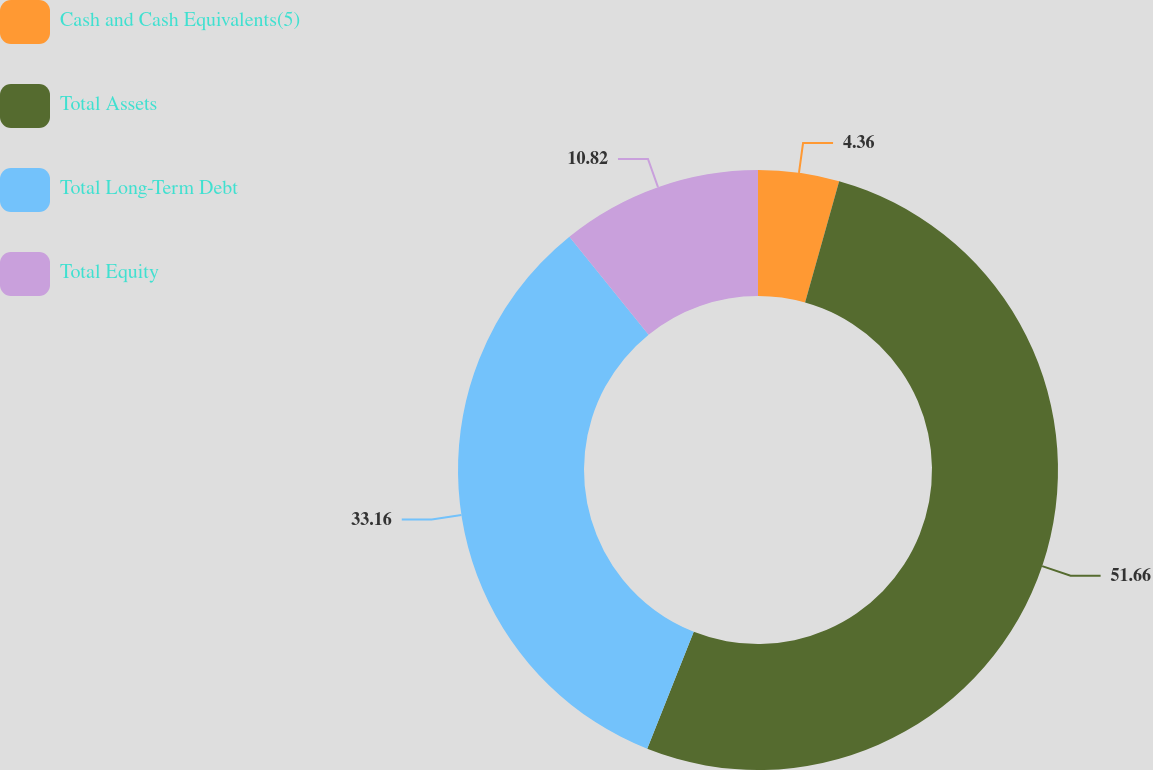Convert chart. <chart><loc_0><loc_0><loc_500><loc_500><pie_chart><fcel>Cash and Cash Equivalents(5)<fcel>Total Assets<fcel>Total Long-Term Debt<fcel>Total Equity<nl><fcel>4.36%<fcel>51.66%<fcel>33.16%<fcel>10.82%<nl></chart> 